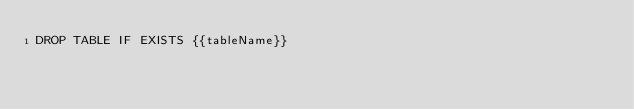Convert code to text. <code><loc_0><loc_0><loc_500><loc_500><_SQL_>DROP TABLE IF EXISTS {{tableName}}</code> 